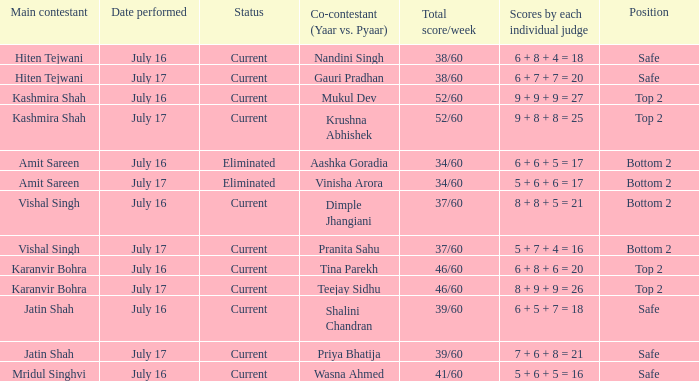Who performed with Tina Parekh? Karanvir Bohra. 